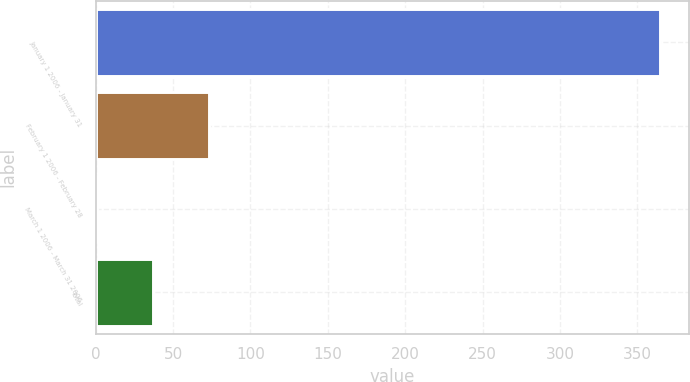<chart> <loc_0><loc_0><loc_500><loc_500><bar_chart><fcel>January 1 2006 - January 31<fcel>February 1 2006 - February 28<fcel>March 1 2006 - March 31 2006<fcel>Total<nl><fcel>364.8<fcel>73.44<fcel>0.6<fcel>37.02<nl></chart> 